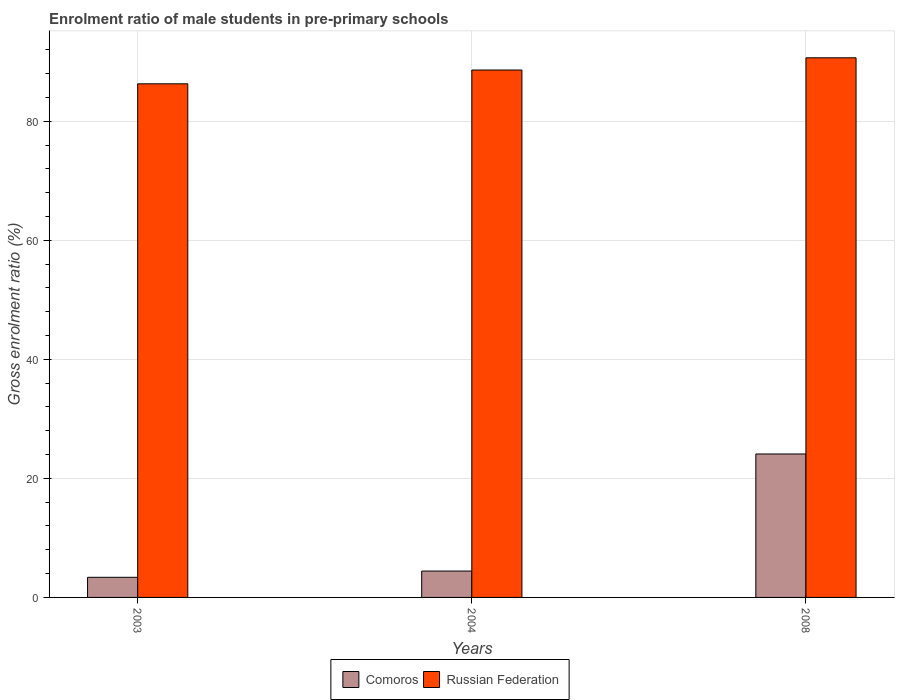Are the number of bars on each tick of the X-axis equal?
Your answer should be very brief. Yes. How many bars are there on the 2nd tick from the right?
Keep it short and to the point. 2. What is the label of the 1st group of bars from the left?
Your response must be concise. 2003. In how many cases, is the number of bars for a given year not equal to the number of legend labels?
Make the answer very short. 0. What is the enrolment ratio of male students in pre-primary schools in Comoros in 2003?
Provide a short and direct response. 3.38. Across all years, what is the maximum enrolment ratio of male students in pre-primary schools in Russian Federation?
Offer a terse response. 90.65. Across all years, what is the minimum enrolment ratio of male students in pre-primary schools in Comoros?
Provide a succinct answer. 3.38. What is the total enrolment ratio of male students in pre-primary schools in Russian Federation in the graph?
Offer a very short reply. 265.53. What is the difference between the enrolment ratio of male students in pre-primary schools in Comoros in 2003 and that in 2008?
Ensure brevity in your answer.  -20.72. What is the difference between the enrolment ratio of male students in pre-primary schools in Russian Federation in 2003 and the enrolment ratio of male students in pre-primary schools in Comoros in 2004?
Your answer should be compact. 81.85. What is the average enrolment ratio of male students in pre-primary schools in Comoros per year?
Your response must be concise. 10.64. In the year 2003, what is the difference between the enrolment ratio of male students in pre-primary schools in Comoros and enrolment ratio of male students in pre-primary schools in Russian Federation?
Your answer should be very brief. -82.9. In how many years, is the enrolment ratio of male students in pre-primary schools in Comoros greater than 52 %?
Make the answer very short. 0. What is the ratio of the enrolment ratio of male students in pre-primary schools in Russian Federation in 2003 to that in 2004?
Your answer should be compact. 0.97. Is the enrolment ratio of male students in pre-primary schools in Comoros in 2003 less than that in 2008?
Ensure brevity in your answer.  Yes. What is the difference between the highest and the second highest enrolment ratio of male students in pre-primary schools in Russian Federation?
Ensure brevity in your answer.  2.05. What is the difference between the highest and the lowest enrolment ratio of male students in pre-primary schools in Russian Federation?
Your answer should be very brief. 4.37. In how many years, is the enrolment ratio of male students in pre-primary schools in Russian Federation greater than the average enrolment ratio of male students in pre-primary schools in Russian Federation taken over all years?
Provide a succinct answer. 2. What does the 2nd bar from the left in 2003 represents?
Offer a very short reply. Russian Federation. What does the 1st bar from the right in 2008 represents?
Offer a very short reply. Russian Federation. How many bars are there?
Your answer should be compact. 6. Are all the bars in the graph horizontal?
Your answer should be compact. No. What is the difference between two consecutive major ticks on the Y-axis?
Your answer should be very brief. 20. Are the values on the major ticks of Y-axis written in scientific E-notation?
Make the answer very short. No. How many legend labels are there?
Your answer should be compact. 2. How are the legend labels stacked?
Keep it short and to the point. Horizontal. What is the title of the graph?
Ensure brevity in your answer.  Enrolment ratio of male students in pre-primary schools. What is the Gross enrolment ratio (%) in Comoros in 2003?
Offer a terse response. 3.38. What is the Gross enrolment ratio (%) in Russian Federation in 2003?
Make the answer very short. 86.28. What is the Gross enrolment ratio (%) of Comoros in 2004?
Keep it short and to the point. 4.43. What is the Gross enrolment ratio (%) in Russian Federation in 2004?
Your answer should be compact. 88.6. What is the Gross enrolment ratio (%) of Comoros in 2008?
Your answer should be compact. 24.1. What is the Gross enrolment ratio (%) in Russian Federation in 2008?
Your response must be concise. 90.65. Across all years, what is the maximum Gross enrolment ratio (%) in Comoros?
Offer a terse response. 24.1. Across all years, what is the maximum Gross enrolment ratio (%) of Russian Federation?
Provide a succinct answer. 90.65. Across all years, what is the minimum Gross enrolment ratio (%) of Comoros?
Give a very brief answer. 3.38. Across all years, what is the minimum Gross enrolment ratio (%) in Russian Federation?
Keep it short and to the point. 86.28. What is the total Gross enrolment ratio (%) of Comoros in the graph?
Your answer should be very brief. 31.91. What is the total Gross enrolment ratio (%) in Russian Federation in the graph?
Your answer should be compact. 265.53. What is the difference between the Gross enrolment ratio (%) of Comoros in 2003 and that in 2004?
Give a very brief answer. -1.05. What is the difference between the Gross enrolment ratio (%) of Russian Federation in 2003 and that in 2004?
Ensure brevity in your answer.  -2.32. What is the difference between the Gross enrolment ratio (%) of Comoros in 2003 and that in 2008?
Keep it short and to the point. -20.72. What is the difference between the Gross enrolment ratio (%) of Russian Federation in 2003 and that in 2008?
Offer a terse response. -4.37. What is the difference between the Gross enrolment ratio (%) in Comoros in 2004 and that in 2008?
Make the answer very short. -19.67. What is the difference between the Gross enrolment ratio (%) in Russian Federation in 2004 and that in 2008?
Ensure brevity in your answer.  -2.05. What is the difference between the Gross enrolment ratio (%) of Comoros in 2003 and the Gross enrolment ratio (%) of Russian Federation in 2004?
Your answer should be very brief. -85.22. What is the difference between the Gross enrolment ratio (%) of Comoros in 2003 and the Gross enrolment ratio (%) of Russian Federation in 2008?
Give a very brief answer. -87.27. What is the difference between the Gross enrolment ratio (%) of Comoros in 2004 and the Gross enrolment ratio (%) of Russian Federation in 2008?
Your response must be concise. -86.22. What is the average Gross enrolment ratio (%) in Comoros per year?
Keep it short and to the point. 10.64. What is the average Gross enrolment ratio (%) in Russian Federation per year?
Provide a succinct answer. 88.51. In the year 2003, what is the difference between the Gross enrolment ratio (%) in Comoros and Gross enrolment ratio (%) in Russian Federation?
Keep it short and to the point. -82.9. In the year 2004, what is the difference between the Gross enrolment ratio (%) in Comoros and Gross enrolment ratio (%) in Russian Federation?
Make the answer very short. -84.17. In the year 2008, what is the difference between the Gross enrolment ratio (%) in Comoros and Gross enrolment ratio (%) in Russian Federation?
Provide a short and direct response. -66.55. What is the ratio of the Gross enrolment ratio (%) in Comoros in 2003 to that in 2004?
Provide a succinct answer. 0.76. What is the ratio of the Gross enrolment ratio (%) of Russian Federation in 2003 to that in 2004?
Your response must be concise. 0.97. What is the ratio of the Gross enrolment ratio (%) in Comoros in 2003 to that in 2008?
Keep it short and to the point. 0.14. What is the ratio of the Gross enrolment ratio (%) in Russian Federation in 2003 to that in 2008?
Your answer should be compact. 0.95. What is the ratio of the Gross enrolment ratio (%) in Comoros in 2004 to that in 2008?
Your answer should be compact. 0.18. What is the ratio of the Gross enrolment ratio (%) in Russian Federation in 2004 to that in 2008?
Give a very brief answer. 0.98. What is the difference between the highest and the second highest Gross enrolment ratio (%) in Comoros?
Ensure brevity in your answer.  19.67. What is the difference between the highest and the second highest Gross enrolment ratio (%) in Russian Federation?
Ensure brevity in your answer.  2.05. What is the difference between the highest and the lowest Gross enrolment ratio (%) of Comoros?
Offer a terse response. 20.72. What is the difference between the highest and the lowest Gross enrolment ratio (%) in Russian Federation?
Make the answer very short. 4.37. 